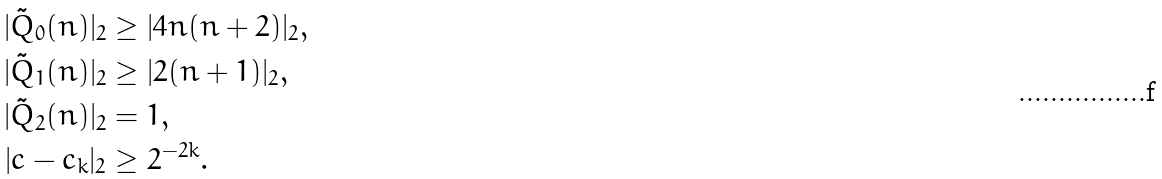Convert formula to latex. <formula><loc_0><loc_0><loc_500><loc_500>| \tilde { Q } _ { 0 } ( n ) | _ { 2 } & \geq | 4 n ( n + 2 ) | _ { 2 } , \\ | \tilde { Q } _ { 1 } ( n ) | _ { 2 } & \geq | 2 ( n + 1 ) | _ { 2 } , \\ | \tilde { Q } _ { 2 } ( n ) | _ { 2 } & = 1 , \\ | c - c _ { k } | _ { 2 } & \geq 2 ^ { - 2 k } .</formula> 